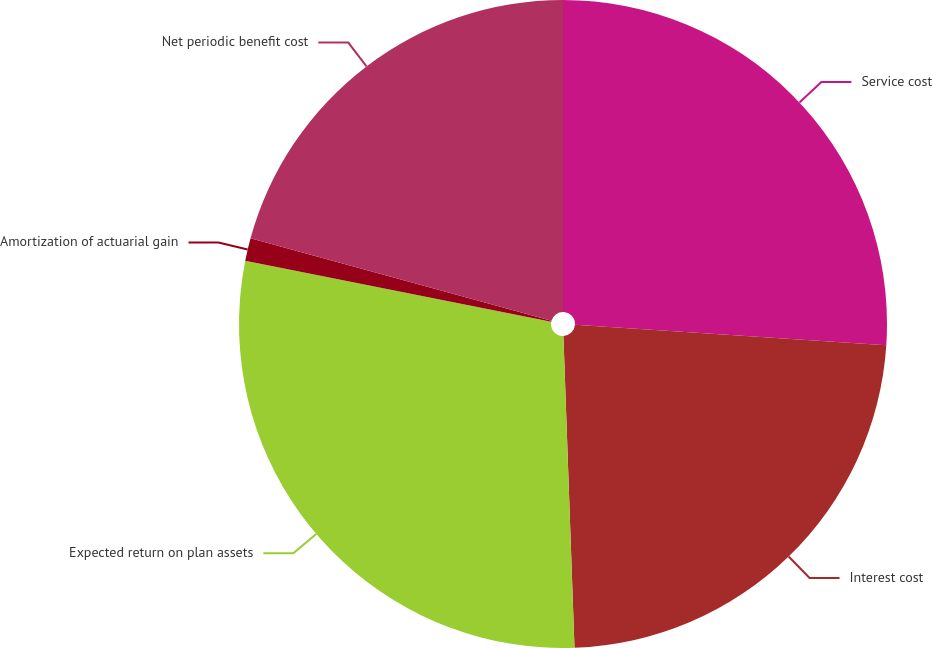Convert chart to OTSL. <chart><loc_0><loc_0><loc_500><loc_500><pie_chart><fcel>Service cost<fcel>Interest cost<fcel>Expected return on plan assets<fcel>Amortization of actuarial gain<fcel>Net periodic benefit cost<nl><fcel>26.04%<fcel>23.39%<fcel>28.69%<fcel>1.13%<fcel>20.74%<nl></chart> 